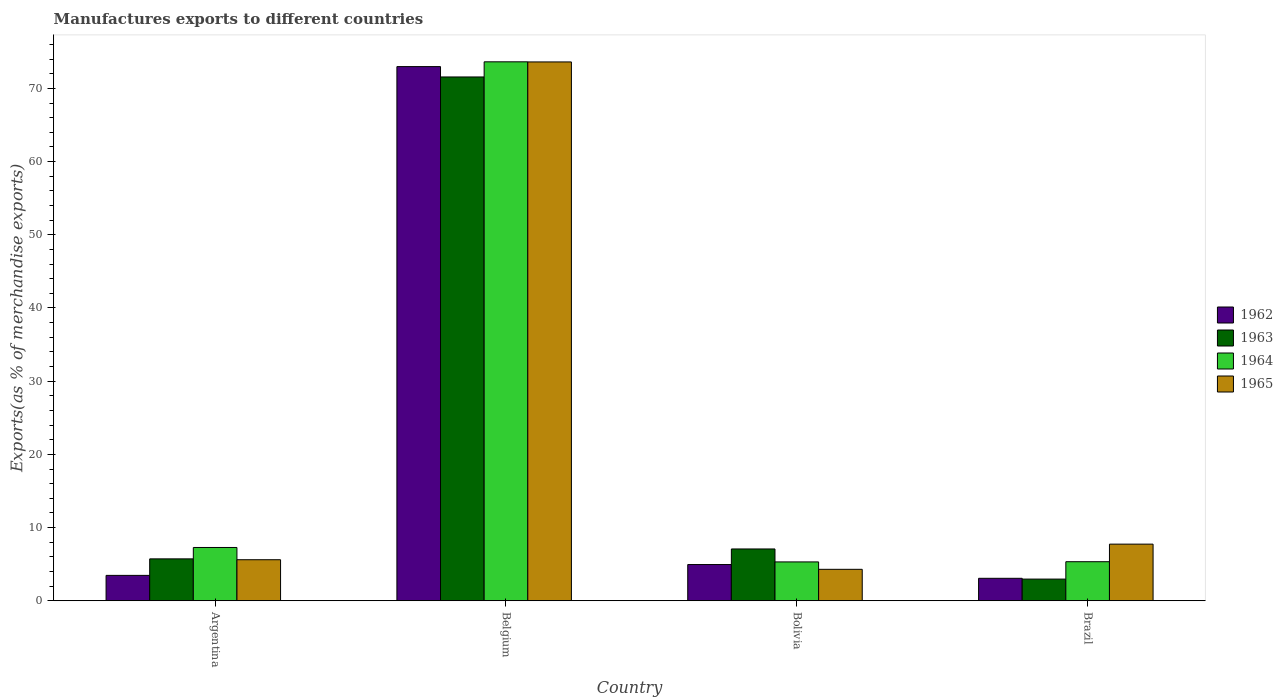How many different coloured bars are there?
Ensure brevity in your answer.  4. Are the number of bars per tick equal to the number of legend labels?
Make the answer very short. Yes. Are the number of bars on each tick of the X-axis equal?
Give a very brief answer. Yes. How many bars are there on the 3rd tick from the right?
Offer a very short reply. 4. What is the label of the 4th group of bars from the left?
Your response must be concise. Brazil. In how many cases, is the number of bars for a given country not equal to the number of legend labels?
Your response must be concise. 0. What is the percentage of exports to different countries in 1963 in Belgium?
Provide a succinct answer. 71.56. Across all countries, what is the maximum percentage of exports to different countries in 1963?
Ensure brevity in your answer.  71.56. Across all countries, what is the minimum percentage of exports to different countries in 1962?
Offer a terse response. 3.07. In which country was the percentage of exports to different countries in 1965 maximum?
Ensure brevity in your answer.  Belgium. In which country was the percentage of exports to different countries in 1962 minimum?
Offer a terse response. Brazil. What is the total percentage of exports to different countries in 1963 in the graph?
Keep it short and to the point. 87.33. What is the difference between the percentage of exports to different countries in 1964 in Argentina and that in Belgium?
Make the answer very short. -66.35. What is the difference between the percentage of exports to different countries in 1962 in Bolivia and the percentage of exports to different countries in 1965 in Brazil?
Offer a very short reply. -2.79. What is the average percentage of exports to different countries in 1963 per country?
Provide a short and direct response. 21.83. What is the difference between the percentage of exports to different countries of/in 1964 and percentage of exports to different countries of/in 1963 in Bolivia?
Keep it short and to the point. -1.77. What is the ratio of the percentage of exports to different countries in 1965 in Belgium to that in Bolivia?
Offer a very short reply. 17.13. Is the percentage of exports to different countries in 1962 in Belgium less than that in Bolivia?
Your response must be concise. No. What is the difference between the highest and the second highest percentage of exports to different countries in 1965?
Give a very brief answer. 68.01. What is the difference between the highest and the lowest percentage of exports to different countries in 1964?
Your answer should be compact. 68.32. Is it the case that in every country, the sum of the percentage of exports to different countries in 1965 and percentage of exports to different countries in 1964 is greater than the sum of percentage of exports to different countries in 1963 and percentage of exports to different countries in 1962?
Give a very brief answer. No. What does the 4th bar from the right in Belgium represents?
Your response must be concise. 1962. Is it the case that in every country, the sum of the percentage of exports to different countries in 1962 and percentage of exports to different countries in 1963 is greater than the percentage of exports to different countries in 1965?
Keep it short and to the point. No. How many countries are there in the graph?
Keep it short and to the point. 4. Does the graph contain grids?
Give a very brief answer. No. How are the legend labels stacked?
Provide a succinct answer. Vertical. What is the title of the graph?
Ensure brevity in your answer.  Manufactures exports to different countries. Does "1982" appear as one of the legend labels in the graph?
Give a very brief answer. No. What is the label or title of the Y-axis?
Keep it short and to the point. Exports(as % of merchandise exports). What is the Exports(as % of merchandise exports) of 1962 in Argentina?
Your answer should be very brief. 3.47. What is the Exports(as % of merchandise exports) of 1963 in Argentina?
Your response must be concise. 5.73. What is the Exports(as % of merchandise exports) in 1964 in Argentina?
Your answer should be compact. 7.28. What is the Exports(as % of merchandise exports) of 1965 in Argentina?
Give a very brief answer. 5.61. What is the Exports(as % of merchandise exports) of 1962 in Belgium?
Offer a terse response. 72.98. What is the Exports(as % of merchandise exports) in 1963 in Belgium?
Your response must be concise. 71.56. What is the Exports(as % of merchandise exports) of 1964 in Belgium?
Give a very brief answer. 73.63. What is the Exports(as % of merchandise exports) of 1965 in Belgium?
Your answer should be compact. 73.62. What is the Exports(as % of merchandise exports) of 1962 in Bolivia?
Your answer should be compact. 4.95. What is the Exports(as % of merchandise exports) of 1963 in Bolivia?
Your answer should be very brief. 7.08. What is the Exports(as % of merchandise exports) in 1964 in Bolivia?
Your answer should be compact. 5.31. What is the Exports(as % of merchandise exports) in 1965 in Bolivia?
Your answer should be very brief. 4.3. What is the Exports(as % of merchandise exports) of 1962 in Brazil?
Provide a short and direct response. 3.07. What is the Exports(as % of merchandise exports) of 1963 in Brazil?
Provide a short and direct response. 2.96. What is the Exports(as % of merchandise exports) in 1964 in Brazil?
Give a very brief answer. 5.34. What is the Exports(as % of merchandise exports) of 1965 in Brazil?
Offer a terse response. 7.74. Across all countries, what is the maximum Exports(as % of merchandise exports) in 1962?
Ensure brevity in your answer.  72.98. Across all countries, what is the maximum Exports(as % of merchandise exports) of 1963?
Keep it short and to the point. 71.56. Across all countries, what is the maximum Exports(as % of merchandise exports) of 1964?
Your response must be concise. 73.63. Across all countries, what is the maximum Exports(as % of merchandise exports) in 1965?
Keep it short and to the point. 73.62. Across all countries, what is the minimum Exports(as % of merchandise exports) in 1962?
Make the answer very short. 3.07. Across all countries, what is the minimum Exports(as % of merchandise exports) in 1963?
Provide a short and direct response. 2.96. Across all countries, what is the minimum Exports(as % of merchandise exports) of 1964?
Offer a terse response. 5.31. Across all countries, what is the minimum Exports(as % of merchandise exports) in 1965?
Offer a terse response. 4.3. What is the total Exports(as % of merchandise exports) of 1962 in the graph?
Keep it short and to the point. 84.47. What is the total Exports(as % of merchandise exports) of 1963 in the graph?
Ensure brevity in your answer.  87.33. What is the total Exports(as % of merchandise exports) of 1964 in the graph?
Your answer should be very brief. 91.56. What is the total Exports(as % of merchandise exports) of 1965 in the graph?
Offer a terse response. 91.26. What is the difference between the Exports(as % of merchandise exports) of 1962 in Argentina and that in Belgium?
Your answer should be compact. -69.51. What is the difference between the Exports(as % of merchandise exports) in 1963 in Argentina and that in Belgium?
Provide a succinct answer. -65.84. What is the difference between the Exports(as % of merchandise exports) in 1964 in Argentina and that in Belgium?
Make the answer very short. -66.35. What is the difference between the Exports(as % of merchandise exports) in 1965 in Argentina and that in Belgium?
Your answer should be compact. -68.01. What is the difference between the Exports(as % of merchandise exports) in 1962 in Argentina and that in Bolivia?
Your answer should be very brief. -1.48. What is the difference between the Exports(as % of merchandise exports) in 1963 in Argentina and that in Bolivia?
Make the answer very short. -1.35. What is the difference between the Exports(as % of merchandise exports) of 1964 in Argentina and that in Bolivia?
Keep it short and to the point. 1.97. What is the difference between the Exports(as % of merchandise exports) of 1965 in Argentina and that in Bolivia?
Make the answer very short. 1.31. What is the difference between the Exports(as % of merchandise exports) of 1962 in Argentina and that in Brazil?
Ensure brevity in your answer.  0.4. What is the difference between the Exports(as % of merchandise exports) of 1963 in Argentina and that in Brazil?
Your answer should be compact. 2.76. What is the difference between the Exports(as % of merchandise exports) in 1964 in Argentina and that in Brazil?
Offer a very short reply. 1.95. What is the difference between the Exports(as % of merchandise exports) in 1965 in Argentina and that in Brazil?
Keep it short and to the point. -2.13. What is the difference between the Exports(as % of merchandise exports) in 1962 in Belgium and that in Bolivia?
Provide a succinct answer. 68.03. What is the difference between the Exports(as % of merchandise exports) of 1963 in Belgium and that in Bolivia?
Give a very brief answer. 64.48. What is the difference between the Exports(as % of merchandise exports) in 1964 in Belgium and that in Bolivia?
Ensure brevity in your answer.  68.32. What is the difference between the Exports(as % of merchandise exports) of 1965 in Belgium and that in Bolivia?
Provide a short and direct response. 69.32. What is the difference between the Exports(as % of merchandise exports) of 1962 in Belgium and that in Brazil?
Your answer should be very brief. 69.91. What is the difference between the Exports(as % of merchandise exports) of 1963 in Belgium and that in Brazil?
Keep it short and to the point. 68.6. What is the difference between the Exports(as % of merchandise exports) of 1964 in Belgium and that in Brazil?
Keep it short and to the point. 68.3. What is the difference between the Exports(as % of merchandise exports) in 1965 in Belgium and that in Brazil?
Your answer should be compact. 65.88. What is the difference between the Exports(as % of merchandise exports) in 1962 in Bolivia and that in Brazil?
Offer a terse response. 1.88. What is the difference between the Exports(as % of merchandise exports) of 1963 in Bolivia and that in Brazil?
Provide a succinct answer. 4.12. What is the difference between the Exports(as % of merchandise exports) of 1964 in Bolivia and that in Brazil?
Provide a short and direct response. -0.03. What is the difference between the Exports(as % of merchandise exports) in 1965 in Bolivia and that in Brazil?
Offer a terse response. -3.44. What is the difference between the Exports(as % of merchandise exports) of 1962 in Argentina and the Exports(as % of merchandise exports) of 1963 in Belgium?
Offer a very short reply. -68.1. What is the difference between the Exports(as % of merchandise exports) in 1962 in Argentina and the Exports(as % of merchandise exports) in 1964 in Belgium?
Make the answer very short. -70.16. What is the difference between the Exports(as % of merchandise exports) of 1962 in Argentina and the Exports(as % of merchandise exports) of 1965 in Belgium?
Give a very brief answer. -70.15. What is the difference between the Exports(as % of merchandise exports) of 1963 in Argentina and the Exports(as % of merchandise exports) of 1964 in Belgium?
Offer a terse response. -67.91. What is the difference between the Exports(as % of merchandise exports) in 1963 in Argentina and the Exports(as % of merchandise exports) in 1965 in Belgium?
Ensure brevity in your answer.  -67.89. What is the difference between the Exports(as % of merchandise exports) in 1964 in Argentina and the Exports(as % of merchandise exports) in 1965 in Belgium?
Offer a very short reply. -66.33. What is the difference between the Exports(as % of merchandise exports) in 1962 in Argentina and the Exports(as % of merchandise exports) in 1963 in Bolivia?
Provide a succinct answer. -3.61. What is the difference between the Exports(as % of merchandise exports) of 1962 in Argentina and the Exports(as % of merchandise exports) of 1964 in Bolivia?
Offer a terse response. -1.84. What is the difference between the Exports(as % of merchandise exports) in 1962 in Argentina and the Exports(as % of merchandise exports) in 1965 in Bolivia?
Your response must be concise. -0.83. What is the difference between the Exports(as % of merchandise exports) of 1963 in Argentina and the Exports(as % of merchandise exports) of 1964 in Bolivia?
Make the answer very short. 0.42. What is the difference between the Exports(as % of merchandise exports) in 1963 in Argentina and the Exports(as % of merchandise exports) in 1965 in Bolivia?
Ensure brevity in your answer.  1.43. What is the difference between the Exports(as % of merchandise exports) in 1964 in Argentina and the Exports(as % of merchandise exports) in 1965 in Bolivia?
Your answer should be very brief. 2.98. What is the difference between the Exports(as % of merchandise exports) of 1962 in Argentina and the Exports(as % of merchandise exports) of 1963 in Brazil?
Keep it short and to the point. 0.51. What is the difference between the Exports(as % of merchandise exports) in 1962 in Argentina and the Exports(as % of merchandise exports) in 1964 in Brazil?
Make the answer very short. -1.87. What is the difference between the Exports(as % of merchandise exports) in 1962 in Argentina and the Exports(as % of merchandise exports) in 1965 in Brazil?
Your answer should be very brief. -4.27. What is the difference between the Exports(as % of merchandise exports) in 1963 in Argentina and the Exports(as % of merchandise exports) in 1964 in Brazil?
Offer a terse response. 0.39. What is the difference between the Exports(as % of merchandise exports) in 1963 in Argentina and the Exports(as % of merchandise exports) in 1965 in Brazil?
Offer a terse response. -2.01. What is the difference between the Exports(as % of merchandise exports) in 1964 in Argentina and the Exports(as % of merchandise exports) in 1965 in Brazil?
Provide a succinct answer. -0.46. What is the difference between the Exports(as % of merchandise exports) of 1962 in Belgium and the Exports(as % of merchandise exports) of 1963 in Bolivia?
Offer a terse response. 65.9. What is the difference between the Exports(as % of merchandise exports) in 1962 in Belgium and the Exports(as % of merchandise exports) in 1964 in Bolivia?
Offer a very short reply. 67.67. What is the difference between the Exports(as % of merchandise exports) of 1962 in Belgium and the Exports(as % of merchandise exports) of 1965 in Bolivia?
Your answer should be very brief. 68.68. What is the difference between the Exports(as % of merchandise exports) in 1963 in Belgium and the Exports(as % of merchandise exports) in 1964 in Bolivia?
Your answer should be compact. 66.25. What is the difference between the Exports(as % of merchandise exports) in 1963 in Belgium and the Exports(as % of merchandise exports) in 1965 in Bolivia?
Make the answer very short. 67.27. What is the difference between the Exports(as % of merchandise exports) of 1964 in Belgium and the Exports(as % of merchandise exports) of 1965 in Bolivia?
Your answer should be compact. 69.34. What is the difference between the Exports(as % of merchandise exports) of 1962 in Belgium and the Exports(as % of merchandise exports) of 1963 in Brazil?
Your response must be concise. 70.02. What is the difference between the Exports(as % of merchandise exports) of 1962 in Belgium and the Exports(as % of merchandise exports) of 1964 in Brazil?
Ensure brevity in your answer.  67.64. What is the difference between the Exports(as % of merchandise exports) of 1962 in Belgium and the Exports(as % of merchandise exports) of 1965 in Brazil?
Your response must be concise. 65.24. What is the difference between the Exports(as % of merchandise exports) in 1963 in Belgium and the Exports(as % of merchandise exports) in 1964 in Brazil?
Provide a succinct answer. 66.23. What is the difference between the Exports(as % of merchandise exports) of 1963 in Belgium and the Exports(as % of merchandise exports) of 1965 in Brazil?
Your response must be concise. 63.82. What is the difference between the Exports(as % of merchandise exports) of 1964 in Belgium and the Exports(as % of merchandise exports) of 1965 in Brazil?
Give a very brief answer. 65.89. What is the difference between the Exports(as % of merchandise exports) of 1962 in Bolivia and the Exports(as % of merchandise exports) of 1963 in Brazil?
Offer a very short reply. 1.99. What is the difference between the Exports(as % of merchandise exports) of 1962 in Bolivia and the Exports(as % of merchandise exports) of 1964 in Brazil?
Keep it short and to the point. -0.39. What is the difference between the Exports(as % of merchandise exports) of 1962 in Bolivia and the Exports(as % of merchandise exports) of 1965 in Brazil?
Give a very brief answer. -2.79. What is the difference between the Exports(as % of merchandise exports) in 1963 in Bolivia and the Exports(as % of merchandise exports) in 1964 in Brazil?
Your answer should be very brief. 1.74. What is the difference between the Exports(as % of merchandise exports) of 1963 in Bolivia and the Exports(as % of merchandise exports) of 1965 in Brazil?
Your answer should be very brief. -0.66. What is the difference between the Exports(as % of merchandise exports) in 1964 in Bolivia and the Exports(as % of merchandise exports) in 1965 in Brazil?
Provide a short and direct response. -2.43. What is the average Exports(as % of merchandise exports) in 1962 per country?
Ensure brevity in your answer.  21.12. What is the average Exports(as % of merchandise exports) in 1963 per country?
Make the answer very short. 21.83. What is the average Exports(as % of merchandise exports) in 1964 per country?
Provide a succinct answer. 22.89. What is the average Exports(as % of merchandise exports) in 1965 per country?
Keep it short and to the point. 22.82. What is the difference between the Exports(as % of merchandise exports) in 1962 and Exports(as % of merchandise exports) in 1963 in Argentina?
Keep it short and to the point. -2.26. What is the difference between the Exports(as % of merchandise exports) in 1962 and Exports(as % of merchandise exports) in 1964 in Argentina?
Provide a short and direct response. -3.81. What is the difference between the Exports(as % of merchandise exports) in 1962 and Exports(as % of merchandise exports) in 1965 in Argentina?
Your answer should be compact. -2.14. What is the difference between the Exports(as % of merchandise exports) of 1963 and Exports(as % of merchandise exports) of 1964 in Argentina?
Offer a terse response. -1.56. What is the difference between the Exports(as % of merchandise exports) in 1963 and Exports(as % of merchandise exports) in 1965 in Argentina?
Make the answer very short. 0.12. What is the difference between the Exports(as % of merchandise exports) of 1964 and Exports(as % of merchandise exports) of 1965 in Argentina?
Your response must be concise. 1.67. What is the difference between the Exports(as % of merchandise exports) in 1962 and Exports(as % of merchandise exports) in 1963 in Belgium?
Offer a terse response. 1.42. What is the difference between the Exports(as % of merchandise exports) of 1962 and Exports(as % of merchandise exports) of 1964 in Belgium?
Offer a terse response. -0.65. What is the difference between the Exports(as % of merchandise exports) of 1962 and Exports(as % of merchandise exports) of 1965 in Belgium?
Your response must be concise. -0.64. What is the difference between the Exports(as % of merchandise exports) in 1963 and Exports(as % of merchandise exports) in 1964 in Belgium?
Offer a very short reply. -2.07. What is the difference between the Exports(as % of merchandise exports) of 1963 and Exports(as % of merchandise exports) of 1965 in Belgium?
Give a very brief answer. -2.05. What is the difference between the Exports(as % of merchandise exports) of 1964 and Exports(as % of merchandise exports) of 1965 in Belgium?
Keep it short and to the point. 0.02. What is the difference between the Exports(as % of merchandise exports) in 1962 and Exports(as % of merchandise exports) in 1963 in Bolivia?
Provide a succinct answer. -2.13. What is the difference between the Exports(as % of merchandise exports) in 1962 and Exports(as % of merchandise exports) in 1964 in Bolivia?
Provide a succinct answer. -0.36. What is the difference between the Exports(as % of merchandise exports) of 1962 and Exports(as % of merchandise exports) of 1965 in Bolivia?
Give a very brief answer. 0.65. What is the difference between the Exports(as % of merchandise exports) of 1963 and Exports(as % of merchandise exports) of 1964 in Bolivia?
Give a very brief answer. 1.77. What is the difference between the Exports(as % of merchandise exports) in 1963 and Exports(as % of merchandise exports) in 1965 in Bolivia?
Ensure brevity in your answer.  2.78. What is the difference between the Exports(as % of merchandise exports) of 1964 and Exports(as % of merchandise exports) of 1965 in Bolivia?
Offer a very short reply. 1.01. What is the difference between the Exports(as % of merchandise exports) in 1962 and Exports(as % of merchandise exports) in 1963 in Brazil?
Your answer should be very brief. 0.11. What is the difference between the Exports(as % of merchandise exports) in 1962 and Exports(as % of merchandise exports) in 1964 in Brazil?
Provide a short and direct response. -2.27. What is the difference between the Exports(as % of merchandise exports) of 1962 and Exports(as % of merchandise exports) of 1965 in Brazil?
Your answer should be compact. -4.67. What is the difference between the Exports(as % of merchandise exports) of 1963 and Exports(as % of merchandise exports) of 1964 in Brazil?
Offer a terse response. -2.37. What is the difference between the Exports(as % of merchandise exports) of 1963 and Exports(as % of merchandise exports) of 1965 in Brazil?
Offer a very short reply. -4.78. What is the difference between the Exports(as % of merchandise exports) in 1964 and Exports(as % of merchandise exports) in 1965 in Brazil?
Your answer should be compact. -2.4. What is the ratio of the Exports(as % of merchandise exports) in 1962 in Argentina to that in Belgium?
Provide a short and direct response. 0.05. What is the ratio of the Exports(as % of merchandise exports) of 1964 in Argentina to that in Belgium?
Offer a very short reply. 0.1. What is the ratio of the Exports(as % of merchandise exports) in 1965 in Argentina to that in Belgium?
Give a very brief answer. 0.08. What is the ratio of the Exports(as % of merchandise exports) of 1962 in Argentina to that in Bolivia?
Your answer should be very brief. 0.7. What is the ratio of the Exports(as % of merchandise exports) of 1963 in Argentina to that in Bolivia?
Offer a very short reply. 0.81. What is the ratio of the Exports(as % of merchandise exports) of 1964 in Argentina to that in Bolivia?
Offer a very short reply. 1.37. What is the ratio of the Exports(as % of merchandise exports) in 1965 in Argentina to that in Bolivia?
Keep it short and to the point. 1.31. What is the ratio of the Exports(as % of merchandise exports) in 1962 in Argentina to that in Brazil?
Your answer should be compact. 1.13. What is the ratio of the Exports(as % of merchandise exports) of 1963 in Argentina to that in Brazil?
Ensure brevity in your answer.  1.93. What is the ratio of the Exports(as % of merchandise exports) of 1964 in Argentina to that in Brazil?
Your answer should be compact. 1.36. What is the ratio of the Exports(as % of merchandise exports) in 1965 in Argentina to that in Brazil?
Provide a short and direct response. 0.72. What is the ratio of the Exports(as % of merchandise exports) of 1962 in Belgium to that in Bolivia?
Your answer should be very brief. 14.74. What is the ratio of the Exports(as % of merchandise exports) of 1963 in Belgium to that in Bolivia?
Give a very brief answer. 10.11. What is the ratio of the Exports(as % of merchandise exports) in 1964 in Belgium to that in Bolivia?
Provide a succinct answer. 13.87. What is the ratio of the Exports(as % of merchandise exports) in 1965 in Belgium to that in Bolivia?
Ensure brevity in your answer.  17.13. What is the ratio of the Exports(as % of merchandise exports) in 1962 in Belgium to that in Brazil?
Offer a very short reply. 23.77. What is the ratio of the Exports(as % of merchandise exports) in 1963 in Belgium to that in Brazil?
Ensure brevity in your answer.  24.16. What is the ratio of the Exports(as % of merchandise exports) of 1964 in Belgium to that in Brazil?
Your response must be concise. 13.8. What is the ratio of the Exports(as % of merchandise exports) of 1965 in Belgium to that in Brazil?
Your response must be concise. 9.51. What is the ratio of the Exports(as % of merchandise exports) in 1962 in Bolivia to that in Brazil?
Ensure brevity in your answer.  1.61. What is the ratio of the Exports(as % of merchandise exports) of 1963 in Bolivia to that in Brazil?
Keep it short and to the point. 2.39. What is the ratio of the Exports(as % of merchandise exports) in 1964 in Bolivia to that in Brazil?
Provide a short and direct response. 0.99. What is the ratio of the Exports(as % of merchandise exports) of 1965 in Bolivia to that in Brazil?
Provide a succinct answer. 0.56. What is the difference between the highest and the second highest Exports(as % of merchandise exports) in 1962?
Your answer should be compact. 68.03. What is the difference between the highest and the second highest Exports(as % of merchandise exports) in 1963?
Provide a short and direct response. 64.48. What is the difference between the highest and the second highest Exports(as % of merchandise exports) in 1964?
Provide a succinct answer. 66.35. What is the difference between the highest and the second highest Exports(as % of merchandise exports) of 1965?
Your response must be concise. 65.88. What is the difference between the highest and the lowest Exports(as % of merchandise exports) in 1962?
Give a very brief answer. 69.91. What is the difference between the highest and the lowest Exports(as % of merchandise exports) of 1963?
Keep it short and to the point. 68.6. What is the difference between the highest and the lowest Exports(as % of merchandise exports) of 1964?
Your response must be concise. 68.32. What is the difference between the highest and the lowest Exports(as % of merchandise exports) in 1965?
Offer a very short reply. 69.32. 